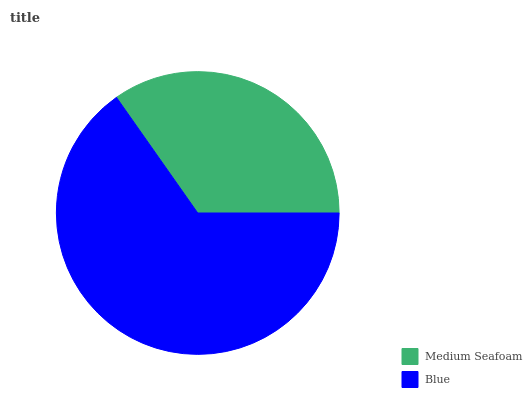Is Medium Seafoam the minimum?
Answer yes or no. Yes. Is Blue the maximum?
Answer yes or no. Yes. Is Blue the minimum?
Answer yes or no. No. Is Blue greater than Medium Seafoam?
Answer yes or no. Yes. Is Medium Seafoam less than Blue?
Answer yes or no. Yes. Is Medium Seafoam greater than Blue?
Answer yes or no. No. Is Blue less than Medium Seafoam?
Answer yes or no. No. Is Blue the high median?
Answer yes or no. Yes. Is Medium Seafoam the low median?
Answer yes or no. Yes. Is Medium Seafoam the high median?
Answer yes or no. No. Is Blue the low median?
Answer yes or no. No. 